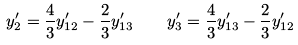<formula> <loc_0><loc_0><loc_500><loc_500>y _ { 2 } ^ { \prime } = { \frac { 4 } { 3 } } y _ { 1 2 } ^ { \prime } - { \frac { 2 } { 3 } } y _ { 1 3 } ^ { \prime } \quad y _ { 3 } ^ { \prime } = { \frac { 4 } { 3 } } y _ { 1 3 } ^ { \prime } - { \frac { 2 } { 3 } } y _ { 1 2 } ^ { \prime }</formula> 